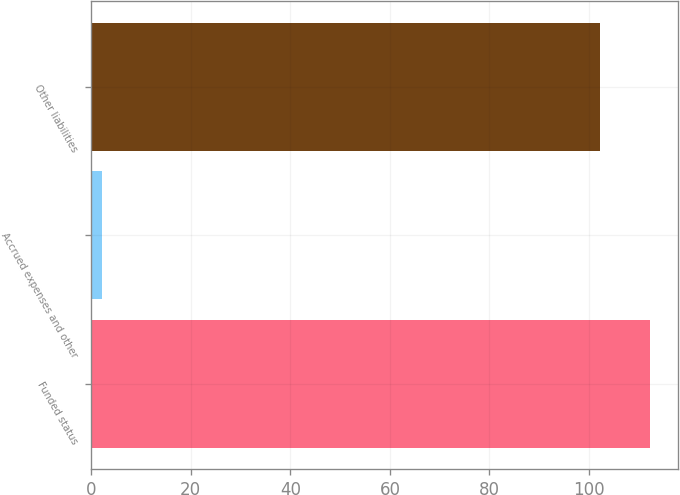Convert chart to OTSL. <chart><loc_0><loc_0><loc_500><loc_500><bar_chart><fcel>Funded status<fcel>Accrued expenses and other<fcel>Other liabilities<nl><fcel>112.31<fcel>2.2<fcel>102.1<nl></chart> 